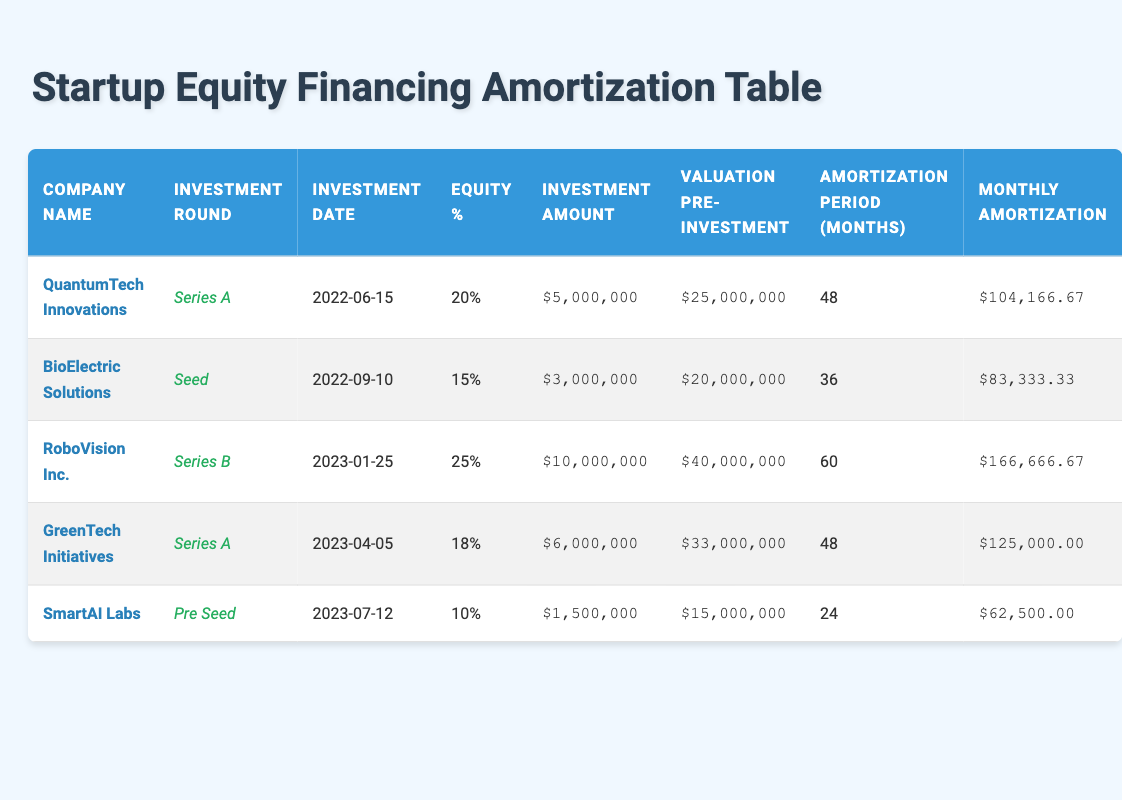What is the investment amount for QuantumTech Innovations? The investment amount is listed in the table under "Investment Amount" for QuantumTech Innovations, which shows $5,000,000.
Answer: $5,000,000 Which company has the longest expected amortization period? The table shows the expected amortization period for each company. RoboVision Inc. has an expected amortization period of 60 months, which is the longest compared to other companies.
Answer: RoboVision Inc What is the average monthly amortization across all companies? To find the average monthly amortization, sum the monthly amortizations for all companies: (104166.67 + 83333.33 + 166666.67 + 125000.00 + 62500.00) = 500666.67. Then, divide by the number of companies (5): 500666.67 / 5 = 100133.33.
Answer: 100133.33 Is the equity percentage for SmartAI Labs greater than 15%? The equity percentage for SmartAI Labs is listed as 10%, which is less than 15%. Therefore, the answer is no.
Answer: No How much more equity percentage does RoboVision Inc. have compared to BioElectric Solutions? RoboVision Inc. has an equity percentage of 25% and BioElectric Solutions has 15%. The difference is calculated as 25% - 15% = 10%.
Answer: 10% What is the total investment amount for all companies combined? To find the total investment amount, sum the individual amounts: (5000000 + 3000000 + 10000000 + 6000000 + 1500000) = 25000000.
Answer: 25000000 Is the valuation before investment for GreenTech Initiatives above $30,000,000? The valuation before investment for GreenTech Initiatives is $33,000,000, which is indeed above $30,000,000. Thus, the answer is yes.
Answer: Yes Which investment round had the lowest monthly amortization? By comparing the monthly amortization values in the table, SmartAI Labs has the lowest monthly amortization of $62,500.00.
Answer: SmartAI Labs How many companies have an expected amortization period of 48 months? Two companies have an expected amortization period of 48 months: QuantumTech Innovations and GreenTech Initiatives.
Answer: 2 